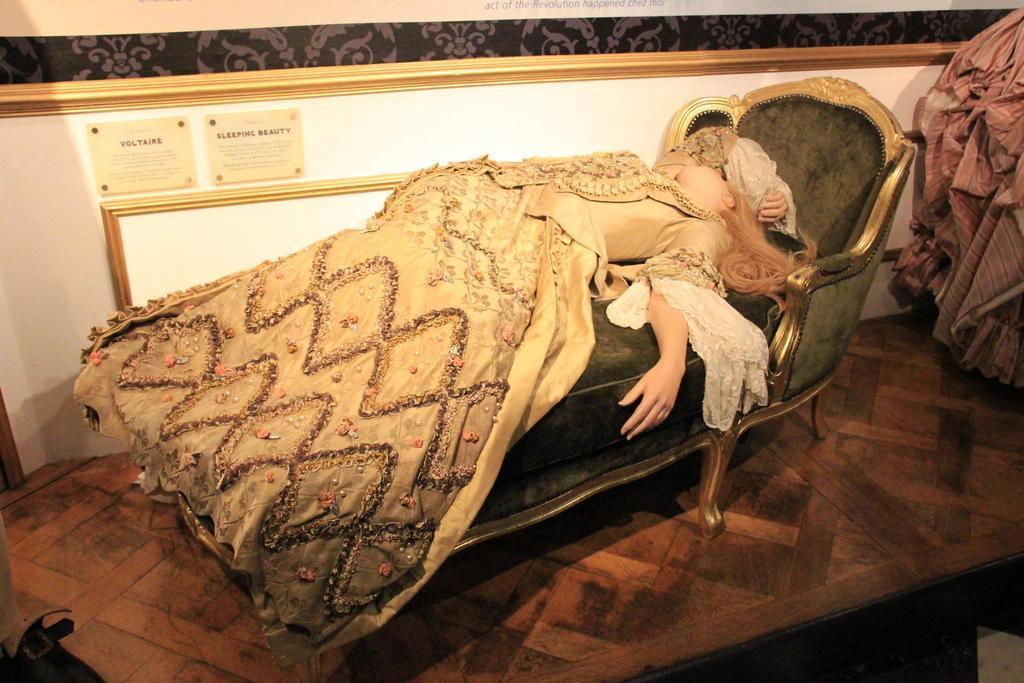How would you summarize this image in a sentence or two? In this image we can see a woman lying on the sofa. And we can see the wall. 